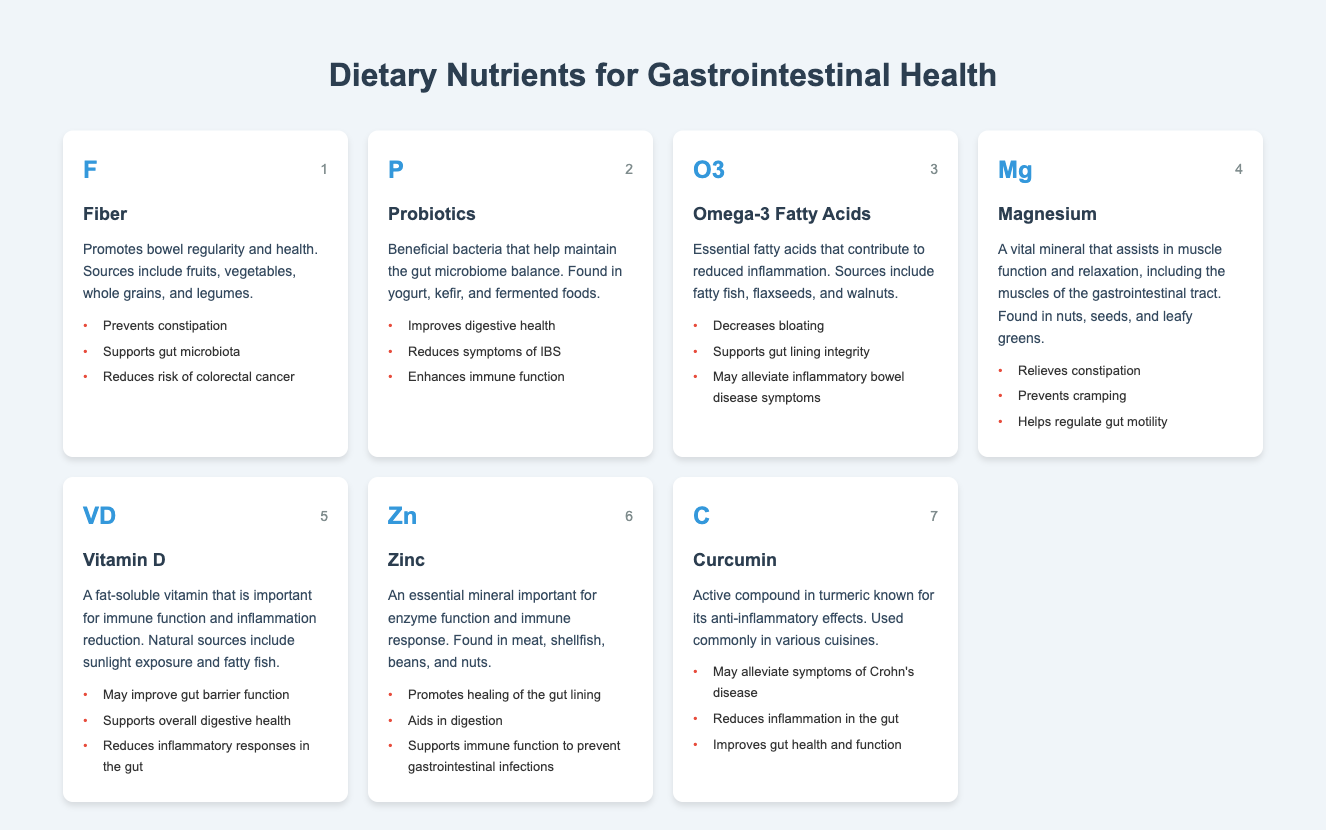What are the health effects of Fiber? The table lists three health effects of Fiber: it prevents constipation, supports gut microbiota, and reduces risk of colorectal cancer. Each of these effects is directly mentioned under the health effects section for Fiber.
Answer: Prevents constipation, supports gut microbiota, reduces risk of colorectal cancer Which nutrient is known for improving digestive health? According to the table, Probiotics are specifically noted for improving digestive health, as stated clearly in the health effects section.
Answer: Probiotics Does Vitamin D support overall digestive health? Yes, the table states that one of the health effects of Vitamin D is that it supports overall digestive health, which confirms the statement as true.
Answer: Yes How many health effects does Omega-3 Fatty Acids have listed? The table indicates that Omega-3 Fatty Acids have three health effects detailed under its entry. This is directly observable as three bullet points under Omega-3 Fatty Acids.
Answer: Three If I take Magnesium, what benefit can I expect related to constipation? Magnesium is stated to relieve constipation as one of its health effects, so if you take Magnesium, you can expect that benefit. This is explicitly mentioned under Magnesium in the health effects section.
Answer: Relieves constipation Between Zinc and Curcumin, which has mentioned benefits toward reducing inflammation in the gut? Both Zinc and Curcumin are listed with benefits related to inflammation. However, while Zinc's benefits focus on healing the gut lining, Curcumin specifically mentions reducing inflammation in the gut. Thus, we see that Curcumin directly addresses inflammation.
Answer: Curcumin What can be inferred about the connection between Probiotics and IBS symptoms? The table specifically mentions that one of the health effects of Probiotics is to reduce symptoms of IBS, indicating a positive connection between the consumption of Probiotics and the alleviation of IBS symptoms.
Answer: Probiotics reduce IBS symptoms List two sources for Omega-3 Fatty Acids. The table outlines sources for Omega-3 Fatty Acids as fatty fish, flaxseeds, and walnuts. Here, we can directly pull two of them as requested.
Answer: Fatty fish, flaxseeds 